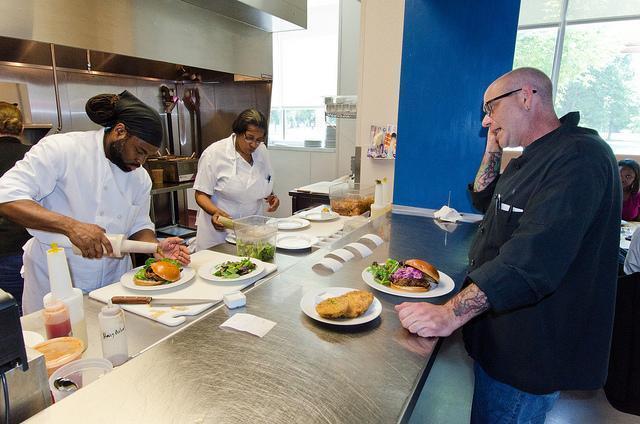How many people can you see?
Give a very brief answer. 4. How many person is wearing orange color t-shirt?
Give a very brief answer. 0. 